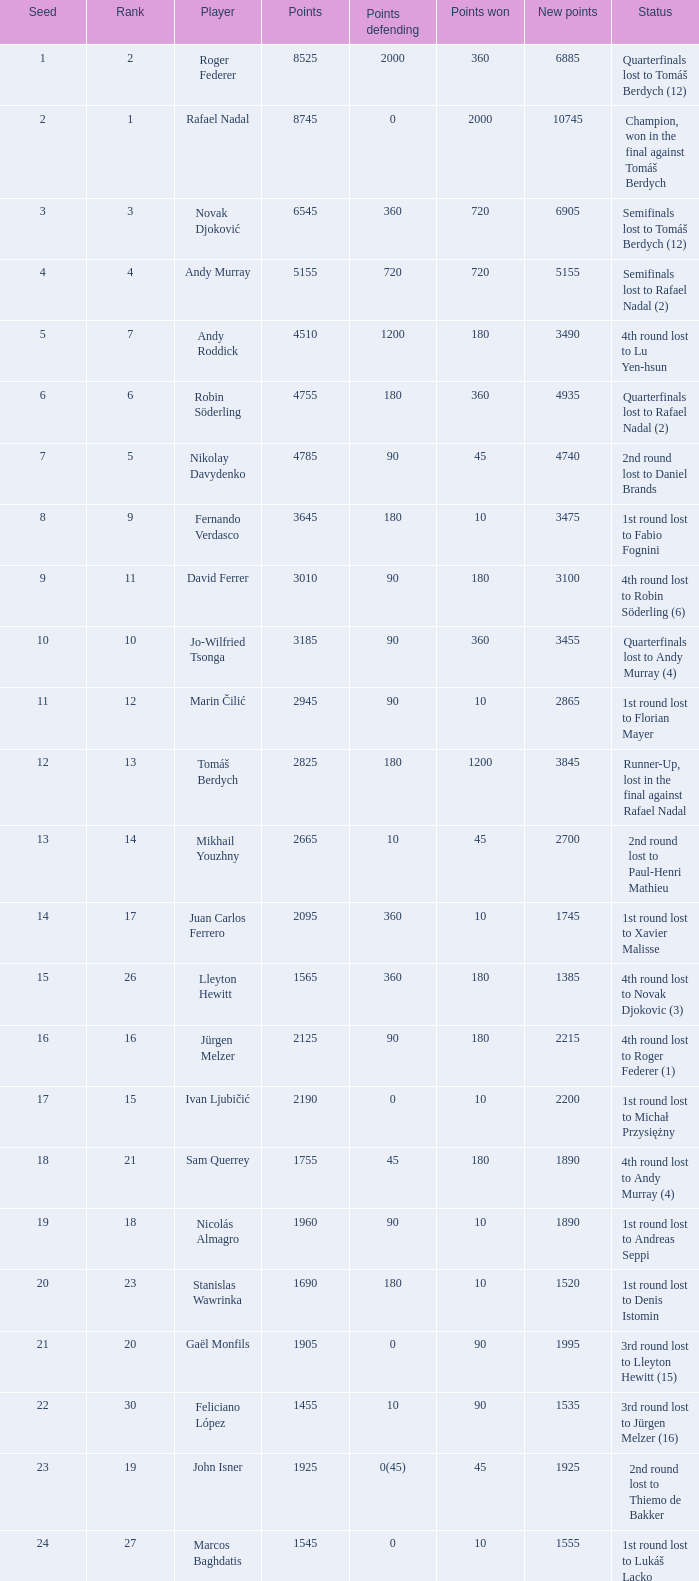What are the points achieved for 1230? 90.0. 